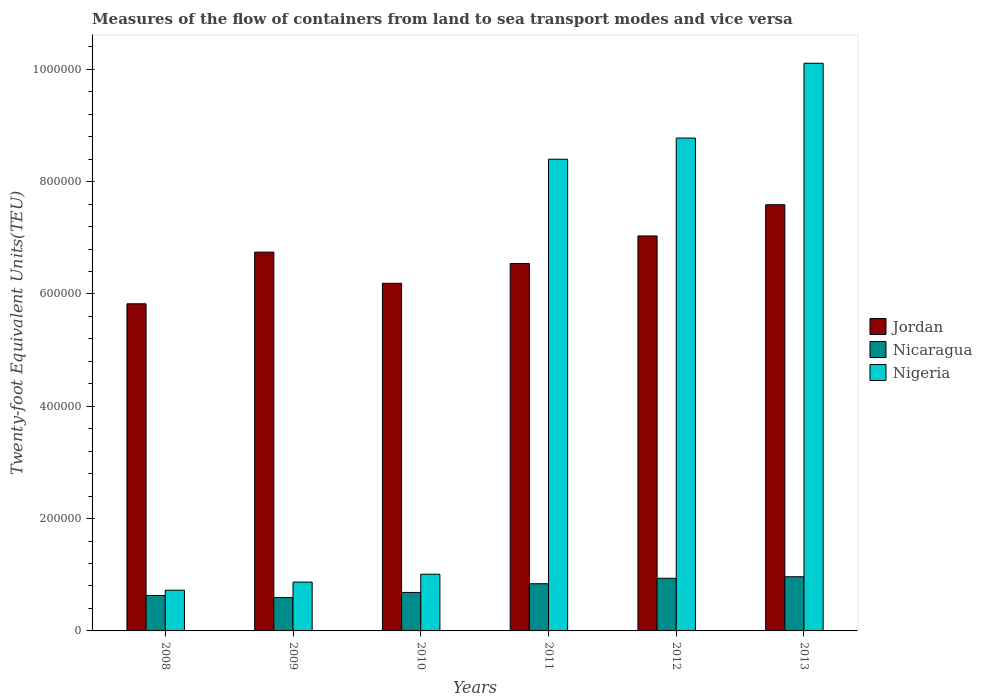How many different coloured bars are there?
Make the answer very short. 3. How many groups of bars are there?
Your response must be concise. 6. Are the number of bars per tick equal to the number of legend labels?
Make the answer very short. Yes. How many bars are there on the 3rd tick from the right?
Keep it short and to the point. 3. What is the label of the 3rd group of bars from the left?
Your answer should be compact. 2010. In how many cases, is the number of bars for a given year not equal to the number of legend labels?
Ensure brevity in your answer.  0. What is the container port traffic in Nicaragua in 2009?
Your response must be concise. 5.95e+04. Across all years, what is the maximum container port traffic in Nigeria?
Provide a short and direct response. 1.01e+06. Across all years, what is the minimum container port traffic in Nigeria?
Keep it short and to the point. 7.25e+04. What is the total container port traffic in Nicaragua in the graph?
Your answer should be compact. 4.65e+05. What is the difference between the container port traffic in Nicaragua in 2010 and that in 2011?
Provide a short and direct response. -1.55e+04. What is the difference between the container port traffic in Jordan in 2008 and the container port traffic in Nicaragua in 2010?
Provide a succinct answer. 5.14e+05. What is the average container port traffic in Nicaragua per year?
Provide a succinct answer. 7.75e+04. In the year 2012, what is the difference between the container port traffic in Nigeria and container port traffic in Nicaragua?
Make the answer very short. 7.84e+05. What is the ratio of the container port traffic in Jordan in 2009 to that in 2012?
Provide a succinct answer. 0.96. Is the container port traffic in Nicaragua in 2011 less than that in 2012?
Provide a succinct answer. Yes. What is the difference between the highest and the second highest container port traffic in Nicaragua?
Provide a short and direct response. 2734.75. What is the difference between the highest and the lowest container port traffic in Jordan?
Provide a succinct answer. 1.76e+05. Is the sum of the container port traffic in Jordan in 2009 and 2013 greater than the maximum container port traffic in Nigeria across all years?
Ensure brevity in your answer.  Yes. What does the 1st bar from the left in 2009 represents?
Give a very brief answer. Jordan. What does the 3rd bar from the right in 2011 represents?
Provide a short and direct response. Jordan. Is it the case that in every year, the sum of the container port traffic in Nicaragua and container port traffic in Nigeria is greater than the container port traffic in Jordan?
Your answer should be very brief. No. How many bars are there?
Make the answer very short. 18. How many years are there in the graph?
Make the answer very short. 6. What is the difference between two consecutive major ticks on the Y-axis?
Offer a very short reply. 2.00e+05. How many legend labels are there?
Offer a terse response. 3. What is the title of the graph?
Your answer should be compact. Measures of the flow of containers from land to sea transport modes and vice versa. What is the label or title of the Y-axis?
Offer a terse response. Twenty-foot Equivalent Units(TEU). What is the Twenty-foot Equivalent Units(TEU) of Jordan in 2008?
Make the answer very short. 5.83e+05. What is the Twenty-foot Equivalent Units(TEU) in Nicaragua in 2008?
Offer a very short reply. 6.30e+04. What is the Twenty-foot Equivalent Units(TEU) of Nigeria in 2008?
Offer a very short reply. 7.25e+04. What is the Twenty-foot Equivalent Units(TEU) of Jordan in 2009?
Your answer should be very brief. 6.75e+05. What is the Twenty-foot Equivalent Units(TEU) in Nicaragua in 2009?
Provide a short and direct response. 5.95e+04. What is the Twenty-foot Equivalent Units(TEU) in Nigeria in 2009?
Make the answer very short. 8.70e+04. What is the Twenty-foot Equivalent Units(TEU) of Jordan in 2010?
Make the answer very short. 6.19e+05. What is the Twenty-foot Equivalent Units(TEU) of Nicaragua in 2010?
Keep it short and to the point. 6.85e+04. What is the Twenty-foot Equivalent Units(TEU) in Nigeria in 2010?
Your answer should be very brief. 1.01e+05. What is the Twenty-foot Equivalent Units(TEU) in Jordan in 2011?
Keep it short and to the point. 6.54e+05. What is the Twenty-foot Equivalent Units(TEU) in Nicaragua in 2011?
Ensure brevity in your answer.  8.40e+04. What is the Twenty-foot Equivalent Units(TEU) in Nigeria in 2011?
Your response must be concise. 8.40e+05. What is the Twenty-foot Equivalent Units(TEU) of Jordan in 2012?
Make the answer very short. 7.03e+05. What is the Twenty-foot Equivalent Units(TEU) of Nicaragua in 2012?
Offer a very short reply. 9.37e+04. What is the Twenty-foot Equivalent Units(TEU) of Nigeria in 2012?
Make the answer very short. 8.78e+05. What is the Twenty-foot Equivalent Units(TEU) of Jordan in 2013?
Your answer should be very brief. 7.59e+05. What is the Twenty-foot Equivalent Units(TEU) in Nicaragua in 2013?
Offer a terse response. 9.65e+04. What is the Twenty-foot Equivalent Units(TEU) of Nigeria in 2013?
Your answer should be very brief. 1.01e+06. Across all years, what is the maximum Twenty-foot Equivalent Units(TEU) in Jordan?
Your response must be concise. 7.59e+05. Across all years, what is the maximum Twenty-foot Equivalent Units(TEU) of Nicaragua?
Your answer should be very brief. 9.65e+04. Across all years, what is the maximum Twenty-foot Equivalent Units(TEU) in Nigeria?
Make the answer very short. 1.01e+06. Across all years, what is the minimum Twenty-foot Equivalent Units(TEU) of Jordan?
Make the answer very short. 5.83e+05. Across all years, what is the minimum Twenty-foot Equivalent Units(TEU) in Nicaragua?
Offer a terse response. 5.95e+04. Across all years, what is the minimum Twenty-foot Equivalent Units(TEU) of Nigeria?
Provide a short and direct response. 7.25e+04. What is the total Twenty-foot Equivalent Units(TEU) of Jordan in the graph?
Offer a very short reply. 3.99e+06. What is the total Twenty-foot Equivalent Units(TEU) in Nicaragua in the graph?
Keep it short and to the point. 4.65e+05. What is the total Twenty-foot Equivalent Units(TEU) in Nigeria in the graph?
Keep it short and to the point. 2.99e+06. What is the difference between the Twenty-foot Equivalent Units(TEU) in Jordan in 2008 and that in 2009?
Your response must be concise. -9.20e+04. What is the difference between the Twenty-foot Equivalent Units(TEU) in Nicaragua in 2008 and that in 2009?
Provide a short and direct response. 3559. What is the difference between the Twenty-foot Equivalent Units(TEU) of Nigeria in 2008 and that in 2009?
Your response must be concise. -1.45e+04. What is the difference between the Twenty-foot Equivalent Units(TEU) in Jordan in 2008 and that in 2010?
Give a very brief answer. -3.65e+04. What is the difference between the Twenty-foot Equivalent Units(TEU) of Nicaragua in 2008 and that in 2010?
Keep it short and to the point. -5515.2. What is the difference between the Twenty-foot Equivalent Units(TEU) of Nigeria in 2008 and that in 2010?
Ensure brevity in your answer.  -2.85e+04. What is the difference between the Twenty-foot Equivalent Units(TEU) of Jordan in 2008 and that in 2011?
Give a very brief answer. -7.18e+04. What is the difference between the Twenty-foot Equivalent Units(TEU) in Nicaragua in 2008 and that in 2011?
Make the answer very short. -2.10e+04. What is the difference between the Twenty-foot Equivalent Units(TEU) in Nigeria in 2008 and that in 2011?
Make the answer very short. -7.67e+05. What is the difference between the Twenty-foot Equivalent Units(TEU) in Jordan in 2008 and that in 2012?
Give a very brief answer. -1.21e+05. What is the difference between the Twenty-foot Equivalent Units(TEU) of Nicaragua in 2008 and that in 2012?
Provide a short and direct response. -3.07e+04. What is the difference between the Twenty-foot Equivalent Units(TEU) of Nigeria in 2008 and that in 2012?
Your answer should be compact. -8.05e+05. What is the difference between the Twenty-foot Equivalent Units(TEU) in Jordan in 2008 and that in 2013?
Make the answer very short. -1.76e+05. What is the difference between the Twenty-foot Equivalent Units(TEU) in Nicaragua in 2008 and that in 2013?
Your response must be concise. -3.34e+04. What is the difference between the Twenty-foot Equivalent Units(TEU) in Nigeria in 2008 and that in 2013?
Your response must be concise. -9.38e+05. What is the difference between the Twenty-foot Equivalent Units(TEU) in Jordan in 2009 and that in 2010?
Your answer should be very brief. 5.55e+04. What is the difference between the Twenty-foot Equivalent Units(TEU) of Nicaragua in 2009 and that in 2010?
Keep it short and to the point. -9074.2. What is the difference between the Twenty-foot Equivalent Units(TEU) of Nigeria in 2009 and that in 2010?
Ensure brevity in your answer.  -1.40e+04. What is the difference between the Twenty-foot Equivalent Units(TEU) of Jordan in 2009 and that in 2011?
Make the answer very short. 2.02e+04. What is the difference between the Twenty-foot Equivalent Units(TEU) of Nicaragua in 2009 and that in 2011?
Your response must be concise. -2.46e+04. What is the difference between the Twenty-foot Equivalent Units(TEU) of Nigeria in 2009 and that in 2011?
Keep it short and to the point. -7.53e+05. What is the difference between the Twenty-foot Equivalent Units(TEU) of Jordan in 2009 and that in 2012?
Ensure brevity in your answer.  -2.88e+04. What is the difference between the Twenty-foot Equivalent Units(TEU) in Nicaragua in 2009 and that in 2012?
Make the answer very short. -3.43e+04. What is the difference between the Twenty-foot Equivalent Units(TEU) of Nigeria in 2009 and that in 2012?
Offer a terse response. -7.91e+05. What is the difference between the Twenty-foot Equivalent Units(TEU) of Jordan in 2009 and that in 2013?
Make the answer very short. -8.44e+04. What is the difference between the Twenty-foot Equivalent Units(TEU) in Nicaragua in 2009 and that in 2013?
Ensure brevity in your answer.  -3.70e+04. What is the difference between the Twenty-foot Equivalent Units(TEU) in Nigeria in 2009 and that in 2013?
Your answer should be compact. -9.24e+05. What is the difference between the Twenty-foot Equivalent Units(TEU) of Jordan in 2010 and that in 2011?
Offer a terse response. -3.53e+04. What is the difference between the Twenty-foot Equivalent Units(TEU) of Nicaragua in 2010 and that in 2011?
Give a very brief answer. -1.55e+04. What is the difference between the Twenty-foot Equivalent Units(TEU) of Nigeria in 2010 and that in 2011?
Your response must be concise. -7.39e+05. What is the difference between the Twenty-foot Equivalent Units(TEU) in Jordan in 2010 and that in 2012?
Your answer should be very brief. -8.44e+04. What is the difference between the Twenty-foot Equivalent Units(TEU) of Nicaragua in 2010 and that in 2012?
Offer a terse response. -2.52e+04. What is the difference between the Twenty-foot Equivalent Units(TEU) in Nigeria in 2010 and that in 2012?
Offer a terse response. -7.77e+05. What is the difference between the Twenty-foot Equivalent Units(TEU) in Jordan in 2010 and that in 2013?
Your response must be concise. -1.40e+05. What is the difference between the Twenty-foot Equivalent Units(TEU) of Nicaragua in 2010 and that in 2013?
Your answer should be very brief. -2.79e+04. What is the difference between the Twenty-foot Equivalent Units(TEU) of Nigeria in 2010 and that in 2013?
Your answer should be compact. -9.10e+05. What is the difference between the Twenty-foot Equivalent Units(TEU) in Jordan in 2011 and that in 2012?
Make the answer very short. -4.91e+04. What is the difference between the Twenty-foot Equivalent Units(TEU) in Nicaragua in 2011 and that in 2012?
Provide a short and direct response. -9695.63. What is the difference between the Twenty-foot Equivalent Units(TEU) in Nigeria in 2011 and that in 2012?
Your answer should be very brief. -3.78e+04. What is the difference between the Twenty-foot Equivalent Units(TEU) of Jordan in 2011 and that in 2013?
Make the answer very short. -1.05e+05. What is the difference between the Twenty-foot Equivalent Units(TEU) of Nicaragua in 2011 and that in 2013?
Offer a terse response. -1.24e+04. What is the difference between the Twenty-foot Equivalent Units(TEU) in Nigeria in 2011 and that in 2013?
Provide a short and direct response. -1.71e+05. What is the difference between the Twenty-foot Equivalent Units(TEU) of Jordan in 2012 and that in 2013?
Your answer should be compact. -5.56e+04. What is the difference between the Twenty-foot Equivalent Units(TEU) in Nicaragua in 2012 and that in 2013?
Give a very brief answer. -2734.75. What is the difference between the Twenty-foot Equivalent Units(TEU) in Nigeria in 2012 and that in 2013?
Your answer should be compact. -1.33e+05. What is the difference between the Twenty-foot Equivalent Units(TEU) of Jordan in 2008 and the Twenty-foot Equivalent Units(TEU) of Nicaragua in 2009?
Offer a terse response. 5.23e+05. What is the difference between the Twenty-foot Equivalent Units(TEU) in Jordan in 2008 and the Twenty-foot Equivalent Units(TEU) in Nigeria in 2009?
Make the answer very short. 4.96e+05. What is the difference between the Twenty-foot Equivalent Units(TEU) in Nicaragua in 2008 and the Twenty-foot Equivalent Units(TEU) in Nigeria in 2009?
Your answer should be compact. -2.40e+04. What is the difference between the Twenty-foot Equivalent Units(TEU) of Jordan in 2008 and the Twenty-foot Equivalent Units(TEU) of Nicaragua in 2010?
Provide a succinct answer. 5.14e+05. What is the difference between the Twenty-foot Equivalent Units(TEU) in Jordan in 2008 and the Twenty-foot Equivalent Units(TEU) in Nigeria in 2010?
Your answer should be very brief. 4.82e+05. What is the difference between the Twenty-foot Equivalent Units(TEU) in Nicaragua in 2008 and the Twenty-foot Equivalent Units(TEU) in Nigeria in 2010?
Make the answer very short. -3.80e+04. What is the difference between the Twenty-foot Equivalent Units(TEU) in Jordan in 2008 and the Twenty-foot Equivalent Units(TEU) in Nicaragua in 2011?
Your answer should be compact. 4.98e+05. What is the difference between the Twenty-foot Equivalent Units(TEU) of Jordan in 2008 and the Twenty-foot Equivalent Units(TEU) of Nigeria in 2011?
Offer a very short reply. -2.57e+05. What is the difference between the Twenty-foot Equivalent Units(TEU) of Nicaragua in 2008 and the Twenty-foot Equivalent Units(TEU) of Nigeria in 2011?
Your answer should be very brief. -7.77e+05. What is the difference between the Twenty-foot Equivalent Units(TEU) of Jordan in 2008 and the Twenty-foot Equivalent Units(TEU) of Nicaragua in 2012?
Provide a succinct answer. 4.89e+05. What is the difference between the Twenty-foot Equivalent Units(TEU) of Jordan in 2008 and the Twenty-foot Equivalent Units(TEU) of Nigeria in 2012?
Provide a succinct answer. -2.95e+05. What is the difference between the Twenty-foot Equivalent Units(TEU) in Nicaragua in 2008 and the Twenty-foot Equivalent Units(TEU) in Nigeria in 2012?
Your answer should be very brief. -8.15e+05. What is the difference between the Twenty-foot Equivalent Units(TEU) in Jordan in 2008 and the Twenty-foot Equivalent Units(TEU) in Nicaragua in 2013?
Your response must be concise. 4.86e+05. What is the difference between the Twenty-foot Equivalent Units(TEU) in Jordan in 2008 and the Twenty-foot Equivalent Units(TEU) in Nigeria in 2013?
Your answer should be very brief. -4.28e+05. What is the difference between the Twenty-foot Equivalent Units(TEU) in Nicaragua in 2008 and the Twenty-foot Equivalent Units(TEU) in Nigeria in 2013?
Give a very brief answer. -9.48e+05. What is the difference between the Twenty-foot Equivalent Units(TEU) in Jordan in 2009 and the Twenty-foot Equivalent Units(TEU) in Nicaragua in 2010?
Your answer should be very brief. 6.06e+05. What is the difference between the Twenty-foot Equivalent Units(TEU) of Jordan in 2009 and the Twenty-foot Equivalent Units(TEU) of Nigeria in 2010?
Keep it short and to the point. 5.74e+05. What is the difference between the Twenty-foot Equivalent Units(TEU) of Nicaragua in 2009 and the Twenty-foot Equivalent Units(TEU) of Nigeria in 2010?
Your response must be concise. -4.15e+04. What is the difference between the Twenty-foot Equivalent Units(TEU) in Jordan in 2009 and the Twenty-foot Equivalent Units(TEU) in Nicaragua in 2011?
Provide a succinct answer. 5.90e+05. What is the difference between the Twenty-foot Equivalent Units(TEU) of Jordan in 2009 and the Twenty-foot Equivalent Units(TEU) of Nigeria in 2011?
Offer a terse response. -1.65e+05. What is the difference between the Twenty-foot Equivalent Units(TEU) of Nicaragua in 2009 and the Twenty-foot Equivalent Units(TEU) of Nigeria in 2011?
Your answer should be very brief. -7.80e+05. What is the difference between the Twenty-foot Equivalent Units(TEU) in Jordan in 2009 and the Twenty-foot Equivalent Units(TEU) in Nicaragua in 2012?
Your answer should be compact. 5.81e+05. What is the difference between the Twenty-foot Equivalent Units(TEU) in Jordan in 2009 and the Twenty-foot Equivalent Units(TEU) in Nigeria in 2012?
Make the answer very short. -2.03e+05. What is the difference between the Twenty-foot Equivalent Units(TEU) of Nicaragua in 2009 and the Twenty-foot Equivalent Units(TEU) of Nigeria in 2012?
Provide a succinct answer. -8.18e+05. What is the difference between the Twenty-foot Equivalent Units(TEU) in Jordan in 2009 and the Twenty-foot Equivalent Units(TEU) in Nicaragua in 2013?
Offer a very short reply. 5.78e+05. What is the difference between the Twenty-foot Equivalent Units(TEU) of Jordan in 2009 and the Twenty-foot Equivalent Units(TEU) of Nigeria in 2013?
Provide a succinct answer. -3.36e+05. What is the difference between the Twenty-foot Equivalent Units(TEU) in Nicaragua in 2009 and the Twenty-foot Equivalent Units(TEU) in Nigeria in 2013?
Your response must be concise. -9.51e+05. What is the difference between the Twenty-foot Equivalent Units(TEU) in Jordan in 2010 and the Twenty-foot Equivalent Units(TEU) in Nicaragua in 2011?
Make the answer very short. 5.35e+05. What is the difference between the Twenty-foot Equivalent Units(TEU) of Jordan in 2010 and the Twenty-foot Equivalent Units(TEU) of Nigeria in 2011?
Make the answer very short. -2.21e+05. What is the difference between the Twenty-foot Equivalent Units(TEU) of Nicaragua in 2010 and the Twenty-foot Equivalent Units(TEU) of Nigeria in 2011?
Make the answer very short. -7.71e+05. What is the difference between the Twenty-foot Equivalent Units(TEU) in Jordan in 2010 and the Twenty-foot Equivalent Units(TEU) in Nicaragua in 2012?
Provide a succinct answer. 5.25e+05. What is the difference between the Twenty-foot Equivalent Units(TEU) of Jordan in 2010 and the Twenty-foot Equivalent Units(TEU) of Nigeria in 2012?
Provide a succinct answer. -2.59e+05. What is the difference between the Twenty-foot Equivalent Units(TEU) in Nicaragua in 2010 and the Twenty-foot Equivalent Units(TEU) in Nigeria in 2012?
Provide a short and direct response. -8.09e+05. What is the difference between the Twenty-foot Equivalent Units(TEU) in Jordan in 2010 and the Twenty-foot Equivalent Units(TEU) in Nicaragua in 2013?
Your response must be concise. 5.23e+05. What is the difference between the Twenty-foot Equivalent Units(TEU) in Jordan in 2010 and the Twenty-foot Equivalent Units(TEU) in Nigeria in 2013?
Offer a very short reply. -3.92e+05. What is the difference between the Twenty-foot Equivalent Units(TEU) in Nicaragua in 2010 and the Twenty-foot Equivalent Units(TEU) in Nigeria in 2013?
Ensure brevity in your answer.  -9.42e+05. What is the difference between the Twenty-foot Equivalent Units(TEU) of Jordan in 2011 and the Twenty-foot Equivalent Units(TEU) of Nicaragua in 2012?
Keep it short and to the point. 5.61e+05. What is the difference between the Twenty-foot Equivalent Units(TEU) of Jordan in 2011 and the Twenty-foot Equivalent Units(TEU) of Nigeria in 2012?
Keep it short and to the point. -2.23e+05. What is the difference between the Twenty-foot Equivalent Units(TEU) in Nicaragua in 2011 and the Twenty-foot Equivalent Units(TEU) in Nigeria in 2012?
Provide a short and direct response. -7.94e+05. What is the difference between the Twenty-foot Equivalent Units(TEU) of Jordan in 2011 and the Twenty-foot Equivalent Units(TEU) of Nicaragua in 2013?
Offer a very short reply. 5.58e+05. What is the difference between the Twenty-foot Equivalent Units(TEU) in Jordan in 2011 and the Twenty-foot Equivalent Units(TEU) in Nigeria in 2013?
Make the answer very short. -3.57e+05. What is the difference between the Twenty-foot Equivalent Units(TEU) of Nicaragua in 2011 and the Twenty-foot Equivalent Units(TEU) of Nigeria in 2013?
Your answer should be very brief. -9.27e+05. What is the difference between the Twenty-foot Equivalent Units(TEU) of Jordan in 2012 and the Twenty-foot Equivalent Units(TEU) of Nicaragua in 2013?
Provide a succinct answer. 6.07e+05. What is the difference between the Twenty-foot Equivalent Units(TEU) of Jordan in 2012 and the Twenty-foot Equivalent Units(TEU) of Nigeria in 2013?
Keep it short and to the point. -3.07e+05. What is the difference between the Twenty-foot Equivalent Units(TEU) of Nicaragua in 2012 and the Twenty-foot Equivalent Units(TEU) of Nigeria in 2013?
Your answer should be very brief. -9.17e+05. What is the average Twenty-foot Equivalent Units(TEU) of Jordan per year?
Provide a short and direct response. 6.65e+05. What is the average Twenty-foot Equivalent Units(TEU) of Nicaragua per year?
Provide a succinct answer. 7.75e+04. What is the average Twenty-foot Equivalent Units(TEU) in Nigeria per year?
Provide a short and direct response. 4.98e+05. In the year 2008, what is the difference between the Twenty-foot Equivalent Units(TEU) in Jordan and Twenty-foot Equivalent Units(TEU) in Nicaragua?
Offer a terse response. 5.19e+05. In the year 2008, what is the difference between the Twenty-foot Equivalent Units(TEU) of Jordan and Twenty-foot Equivalent Units(TEU) of Nigeria?
Your answer should be very brief. 5.10e+05. In the year 2008, what is the difference between the Twenty-foot Equivalent Units(TEU) of Nicaragua and Twenty-foot Equivalent Units(TEU) of Nigeria?
Provide a short and direct response. -9470. In the year 2009, what is the difference between the Twenty-foot Equivalent Units(TEU) of Jordan and Twenty-foot Equivalent Units(TEU) of Nicaragua?
Ensure brevity in your answer.  6.15e+05. In the year 2009, what is the difference between the Twenty-foot Equivalent Units(TEU) of Jordan and Twenty-foot Equivalent Units(TEU) of Nigeria?
Offer a terse response. 5.88e+05. In the year 2009, what is the difference between the Twenty-foot Equivalent Units(TEU) of Nicaragua and Twenty-foot Equivalent Units(TEU) of Nigeria?
Make the answer very short. -2.75e+04. In the year 2010, what is the difference between the Twenty-foot Equivalent Units(TEU) of Jordan and Twenty-foot Equivalent Units(TEU) of Nicaragua?
Provide a succinct answer. 5.50e+05. In the year 2010, what is the difference between the Twenty-foot Equivalent Units(TEU) of Jordan and Twenty-foot Equivalent Units(TEU) of Nigeria?
Offer a terse response. 5.18e+05. In the year 2010, what is the difference between the Twenty-foot Equivalent Units(TEU) in Nicaragua and Twenty-foot Equivalent Units(TEU) in Nigeria?
Offer a terse response. -3.25e+04. In the year 2011, what is the difference between the Twenty-foot Equivalent Units(TEU) of Jordan and Twenty-foot Equivalent Units(TEU) of Nicaragua?
Provide a short and direct response. 5.70e+05. In the year 2011, what is the difference between the Twenty-foot Equivalent Units(TEU) of Jordan and Twenty-foot Equivalent Units(TEU) of Nigeria?
Your response must be concise. -1.86e+05. In the year 2011, what is the difference between the Twenty-foot Equivalent Units(TEU) in Nicaragua and Twenty-foot Equivalent Units(TEU) in Nigeria?
Ensure brevity in your answer.  -7.56e+05. In the year 2012, what is the difference between the Twenty-foot Equivalent Units(TEU) in Jordan and Twenty-foot Equivalent Units(TEU) in Nicaragua?
Provide a short and direct response. 6.10e+05. In the year 2012, what is the difference between the Twenty-foot Equivalent Units(TEU) in Jordan and Twenty-foot Equivalent Units(TEU) in Nigeria?
Offer a very short reply. -1.74e+05. In the year 2012, what is the difference between the Twenty-foot Equivalent Units(TEU) in Nicaragua and Twenty-foot Equivalent Units(TEU) in Nigeria?
Ensure brevity in your answer.  -7.84e+05. In the year 2013, what is the difference between the Twenty-foot Equivalent Units(TEU) of Jordan and Twenty-foot Equivalent Units(TEU) of Nicaragua?
Give a very brief answer. 6.62e+05. In the year 2013, what is the difference between the Twenty-foot Equivalent Units(TEU) of Jordan and Twenty-foot Equivalent Units(TEU) of Nigeria?
Your answer should be very brief. -2.52e+05. In the year 2013, what is the difference between the Twenty-foot Equivalent Units(TEU) in Nicaragua and Twenty-foot Equivalent Units(TEU) in Nigeria?
Keep it short and to the point. -9.14e+05. What is the ratio of the Twenty-foot Equivalent Units(TEU) in Jordan in 2008 to that in 2009?
Make the answer very short. 0.86. What is the ratio of the Twenty-foot Equivalent Units(TEU) in Nicaragua in 2008 to that in 2009?
Offer a very short reply. 1.06. What is the ratio of the Twenty-foot Equivalent Units(TEU) of Jordan in 2008 to that in 2010?
Ensure brevity in your answer.  0.94. What is the ratio of the Twenty-foot Equivalent Units(TEU) in Nicaragua in 2008 to that in 2010?
Offer a terse response. 0.92. What is the ratio of the Twenty-foot Equivalent Units(TEU) of Nigeria in 2008 to that in 2010?
Offer a very short reply. 0.72. What is the ratio of the Twenty-foot Equivalent Units(TEU) of Jordan in 2008 to that in 2011?
Your answer should be compact. 0.89. What is the ratio of the Twenty-foot Equivalent Units(TEU) in Nicaragua in 2008 to that in 2011?
Make the answer very short. 0.75. What is the ratio of the Twenty-foot Equivalent Units(TEU) of Nigeria in 2008 to that in 2011?
Your answer should be compact. 0.09. What is the ratio of the Twenty-foot Equivalent Units(TEU) of Jordan in 2008 to that in 2012?
Provide a succinct answer. 0.83. What is the ratio of the Twenty-foot Equivalent Units(TEU) of Nicaragua in 2008 to that in 2012?
Make the answer very short. 0.67. What is the ratio of the Twenty-foot Equivalent Units(TEU) of Nigeria in 2008 to that in 2012?
Your response must be concise. 0.08. What is the ratio of the Twenty-foot Equivalent Units(TEU) in Jordan in 2008 to that in 2013?
Provide a succinct answer. 0.77. What is the ratio of the Twenty-foot Equivalent Units(TEU) of Nicaragua in 2008 to that in 2013?
Ensure brevity in your answer.  0.65. What is the ratio of the Twenty-foot Equivalent Units(TEU) of Nigeria in 2008 to that in 2013?
Make the answer very short. 0.07. What is the ratio of the Twenty-foot Equivalent Units(TEU) of Jordan in 2009 to that in 2010?
Keep it short and to the point. 1.09. What is the ratio of the Twenty-foot Equivalent Units(TEU) in Nicaragua in 2009 to that in 2010?
Ensure brevity in your answer.  0.87. What is the ratio of the Twenty-foot Equivalent Units(TEU) in Nigeria in 2009 to that in 2010?
Ensure brevity in your answer.  0.86. What is the ratio of the Twenty-foot Equivalent Units(TEU) in Jordan in 2009 to that in 2011?
Give a very brief answer. 1.03. What is the ratio of the Twenty-foot Equivalent Units(TEU) of Nicaragua in 2009 to that in 2011?
Give a very brief answer. 0.71. What is the ratio of the Twenty-foot Equivalent Units(TEU) of Nigeria in 2009 to that in 2011?
Keep it short and to the point. 0.1. What is the ratio of the Twenty-foot Equivalent Units(TEU) of Jordan in 2009 to that in 2012?
Give a very brief answer. 0.96. What is the ratio of the Twenty-foot Equivalent Units(TEU) in Nicaragua in 2009 to that in 2012?
Make the answer very short. 0.63. What is the ratio of the Twenty-foot Equivalent Units(TEU) of Nigeria in 2009 to that in 2012?
Provide a short and direct response. 0.1. What is the ratio of the Twenty-foot Equivalent Units(TEU) of Jordan in 2009 to that in 2013?
Keep it short and to the point. 0.89. What is the ratio of the Twenty-foot Equivalent Units(TEU) of Nicaragua in 2009 to that in 2013?
Provide a short and direct response. 0.62. What is the ratio of the Twenty-foot Equivalent Units(TEU) in Nigeria in 2009 to that in 2013?
Provide a short and direct response. 0.09. What is the ratio of the Twenty-foot Equivalent Units(TEU) in Jordan in 2010 to that in 2011?
Offer a very short reply. 0.95. What is the ratio of the Twenty-foot Equivalent Units(TEU) of Nicaragua in 2010 to that in 2011?
Offer a very short reply. 0.82. What is the ratio of the Twenty-foot Equivalent Units(TEU) of Nigeria in 2010 to that in 2011?
Your answer should be compact. 0.12. What is the ratio of the Twenty-foot Equivalent Units(TEU) of Jordan in 2010 to that in 2012?
Your response must be concise. 0.88. What is the ratio of the Twenty-foot Equivalent Units(TEU) of Nicaragua in 2010 to that in 2012?
Keep it short and to the point. 0.73. What is the ratio of the Twenty-foot Equivalent Units(TEU) of Nigeria in 2010 to that in 2012?
Make the answer very short. 0.12. What is the ratio of the Twenty-foot Equivalent Units(TEU) in Jordan in 2010 to that in 2013?
Provide a short and direct response. 0.82. What is the ratio of the Twenty-foot Equivalent Units(TEU) of Nicaragua in 2010 to that in 2013?
Offer a very short reply. 0.71. What is the ratio of the Twenty-foot Equivalent Units(TEU) of Nigeria in 2010 to that in 2013?
Make the answer very short. 0.1. What is the ratio of the Twenty-foot Equivalent Units(TEU) in Jordan in 2011 to that in 2012?
Your answer should be very brief. 0.93. What is the ratio of the Twenty-foot Equivalent Units(TEU) in Nicaragua in 2011 to that in 2012?
Your response must be concise. 0.9. What is the ratio of the Twenty-foot Equivalent Units(TEU) of Nigeria in 2011 to that in 2012?
Provide a short and direct response. 0.96. What is the ratio of the Twenty-foot Equivalent Units(TEU) of Jordan in 2011 to that in 2013?
Your answer should be very brief. 0.86. What is the ratio of the Twenty-foot Equivalent Units(TEU) of Nicaragua in 2011 to that in 2013?
Keep it short and to the point. 0.87. What is the ratio of the Twenty-foot Equivalent Units(TEU) of Nigeria in 2011 to that in 2013?
Offer a very short reply. 0.83. What is the ratio of the Twenty-foot Equivalent Units(TEU) of Jordan in 2012 to that in 2013?
Give a very brief answer. 0.93. What is the ratio of the Twenty-foot Equivalent Units(TEU) of Nicaragua in 2012 to that in 2013?
Give a very brief answer. 0.97. What is the ratio of the Twenty-foot Equivalent Units(TEU) in Nigeria in 2012 to that in 2013?
Offer a very short reply. 0.87. What is the difference between the highest and the second highest Twenty-foot Equivalent Units(TEU) of Jordan?
Your answer should be very brief. 5.56e+04. What is the difference between the highest and the second highest Twenty-foot Equivalent Units(TEU) in Nicaragua?
Your answer should be compact. 2734.75. What is the difference between the highest and the second highest Twenty-foot Equivalent Units(TEU) in Nigeria?
Ensure brevity in your answer.  1.33e+05. What is the difference between the highest and the lowest Twenty-foot Equivalent Units(TEU) of Jordan?
Give a very brief answer. 1.76e+05. What is the difference between the highest and the lowest Twenty-foot Equivalent Units(TEU) of Nicaragua?
Your response must be concise. 3.70e+04. What is the difference between the highest and the lowest Twenty-foot Equivalent Units(TEU) of Nigeria?
Offer a very short reply. 9.38e+05. 